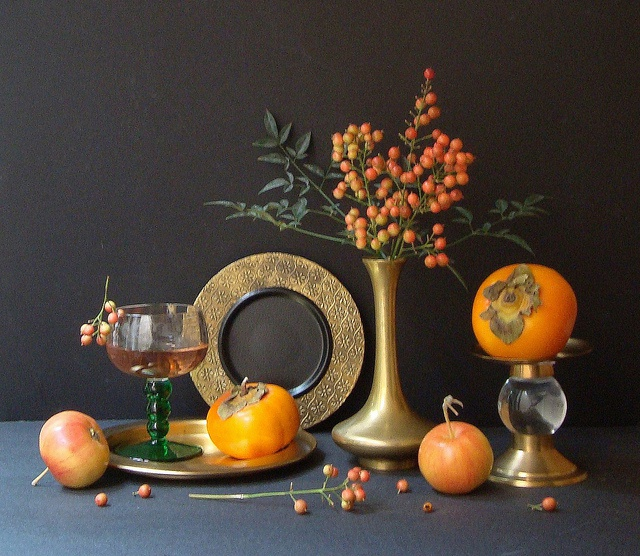Describe the objects in this image and their specific colors. I can see wine glass in black, gray, and maroon tones, vase in black, olive, and tan tones, orange in black, red, brown, orange, and olive tones, orange in black, orange, red, and gold tones, and apple in black, orange, tan, olive, and lightgray tones in this image. 